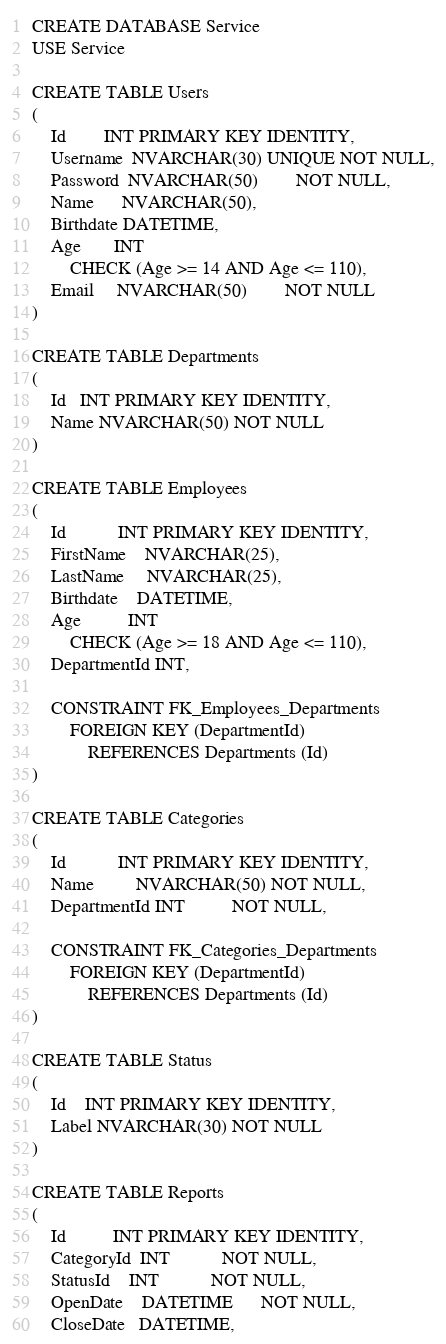<code> <loc_0><loc_0><loc_500><loc_500><_SQL_>CREATE DATABASE Service
USE Service

CREATE TABLE Users
(
    Id        INT PRIMARY KEY IDENTITY,
    Username  NVARCHAR(30) UNIQUE NOT NULL,
    Password  NVARCHAR(50)        NOT NULL,
    Name      NVARCHAR(50),
    Birthdate DATETIME,
    Age       INT
        CHECK (Age >= 14 AND Age <= 110),
    Email     NVARCHAR(50)        NOT NULL
)

CREATE TABLE Departments
(
    Id   INT PRIMARY KEY IDENTITY,
    Name NVARCHAR(50) NOT NULL
)

CREATE TABLE Employees
(
    Id           INT PRIMARY KEY IDENTITY,
    FirstName    NVARCHAR(25),
    LastName     NVARCHAR(25),
    Birthdate    DATETIME,
    Age          INT
        CHECK (Age >= 18 AND Age <= 110),
    DepartmentId INT,

    CONSTRAINT FK_Employees_Departments
        FOREIGN KEY (DepartmentId)
            REFERENCES Departments (Id)
)

CREATE TABLE Categories
(
    Id           INT PRIMARY KEY IDENTITY,
    Name         NVARCHAR(50) NOT NULL,
    DepartmentId INT          NOT NULL,

    CONSTRAINT FK_Categories_Departments
        FOREIGN KEY (DepartmentId)
            REFERENCES Departments (Id)
)

CREATE TABLE Status
(
    Id    INT PRIMARY KEY IDENTITY,
    Label NVARCHAR(30) NOT NULL
)

CREATE TABLE Reports
(
    Id          INT PRIMARY KEY IDENTITY,
    CategoryId  INT           NOT NULL,
    StatusId    INT           NOT NULL,
    OpenDate    DATETIME      NOT NULL,
    CloseDate   DATETIME,</code> 